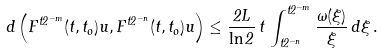<formula> <loc_0><loc_0><loc_500><loc_500>d \left ( F ^ { t 2 ^ { - m } } ( t , t _ { o } ) u , F ^ { t 2 ^ { - n } } ( t , t _ { o } ) u \right ) \leq \frac { 2 L } { \ln 2 } \, t \, \int _ { t 2 ^ { - n } } ^ { t 2 ^ { - m } } \frac { \omega ( \xi ) } { \xi } \, d \xi \, .</formula> 